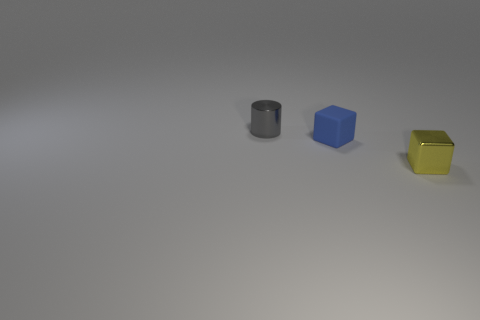Are there any other things that are the same material as the small blue block?
Your response must be concise. No. There is a gray object that is the same size as the blue object; what material is it?
Ensure brevity in your answer.  Metal. What number of objects are gray blocks or matte blocks?
Your answer should be very brief. 1. What number of small objects are on the right side of the cylinder and behind the yellow shiny object?
Provide a succinct answer. 1. Is the number of gray things that are behind the gray metallic thing less than the number of yellow shiny cubes?
Your answer should be compact. Yes. What is the shape of the other gray thing that is the same size as the matte object?
Ensure brevity in your answer.  Cylinder. What number of other objects are the same color as the shiny cylinder?
Ensure brevity in your answer.  0. How many objects are gray cylinders or tiny shiny objects that are to the left of the shiny block?
Keep it short and to the point. 1. Are there fewer yellow things to the left of the small blue matte object than gray metallic things behind the small yellow block?
Your response must be concise. Yes. How many other objects are the same material as the gray cylinder?
Your response must be concise. 1. 